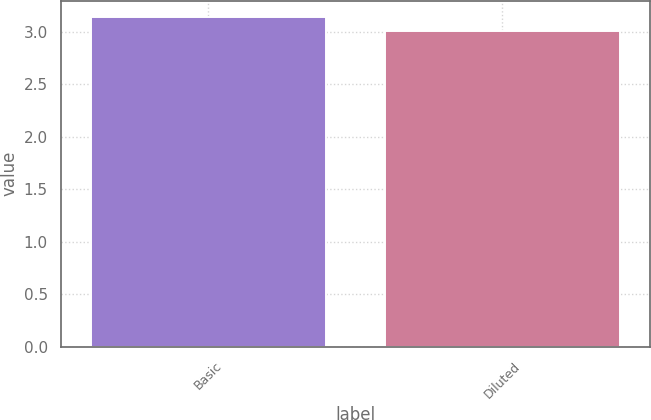Convert chart. <chart><loc_0><loc_0><loc_500><loc_500><bar_chart><fcel>Basic<fcel>Diluted<nl><fcel>3.14<fcel>3.01<nl></chart> 